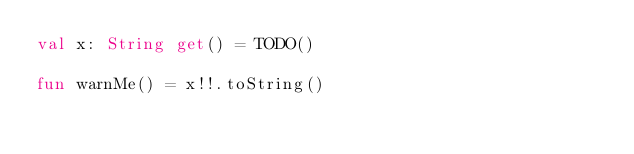<code> <loc_0><loc_0><loc_500><loc_500><_Kotlin_>val x: String get() = TODO()

fun warnMe() = x!!.toString()</code> 